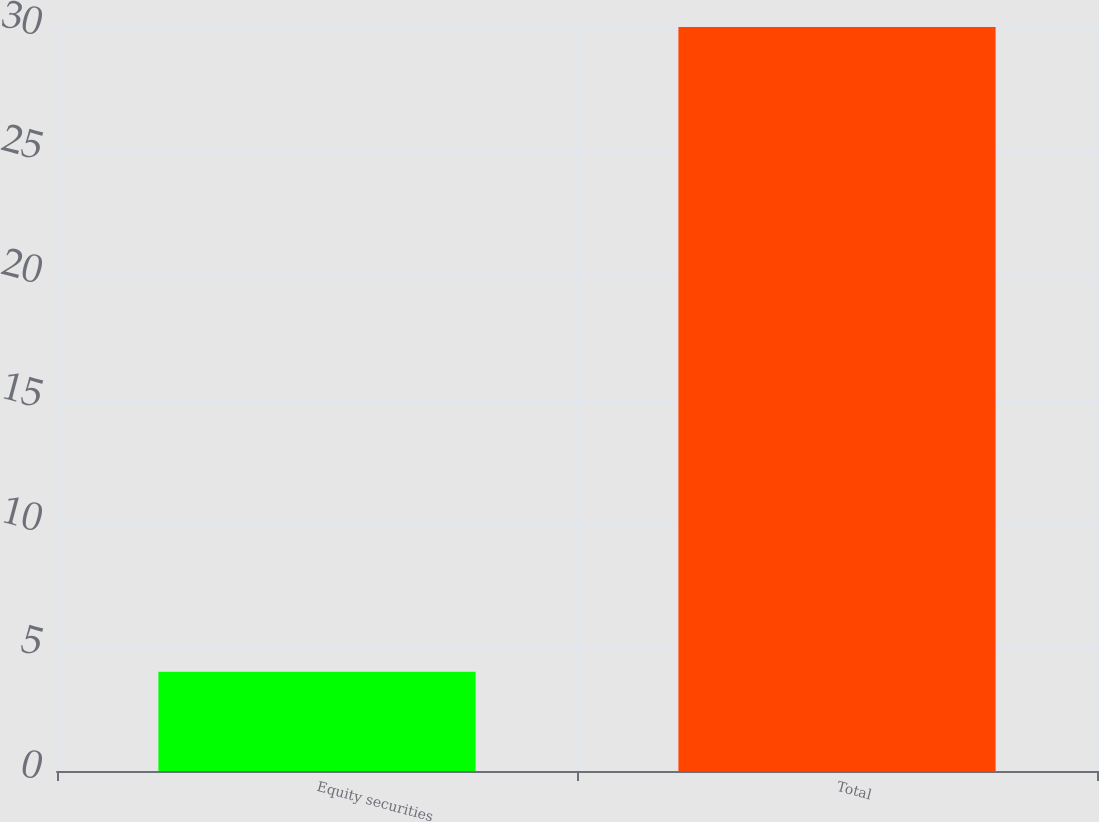Convert chart to OTSL. <chart><loc_0><loc_0><loc_500><loc_500><bar_chart><fcel>Equity securities<fcel>Total<nl><fcel>4<fcel>30<nl></chart> 